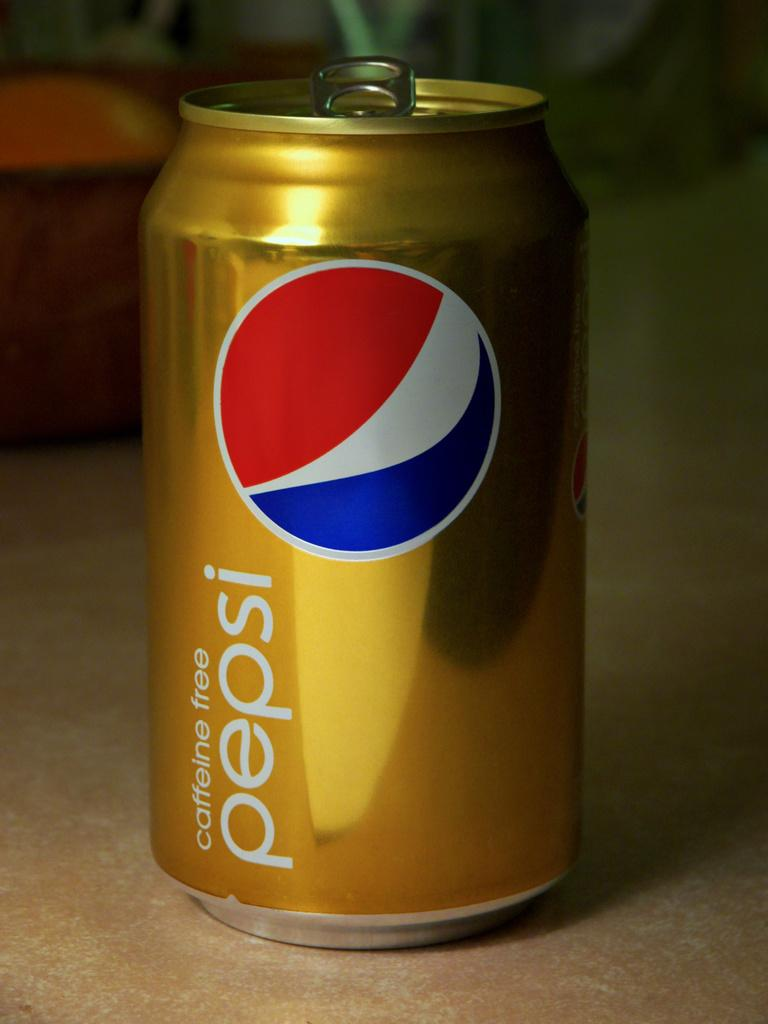<image>
Summarize the visual content of the image. Gold Pepsi Can that is Caffeine Free and is open from the lid. 